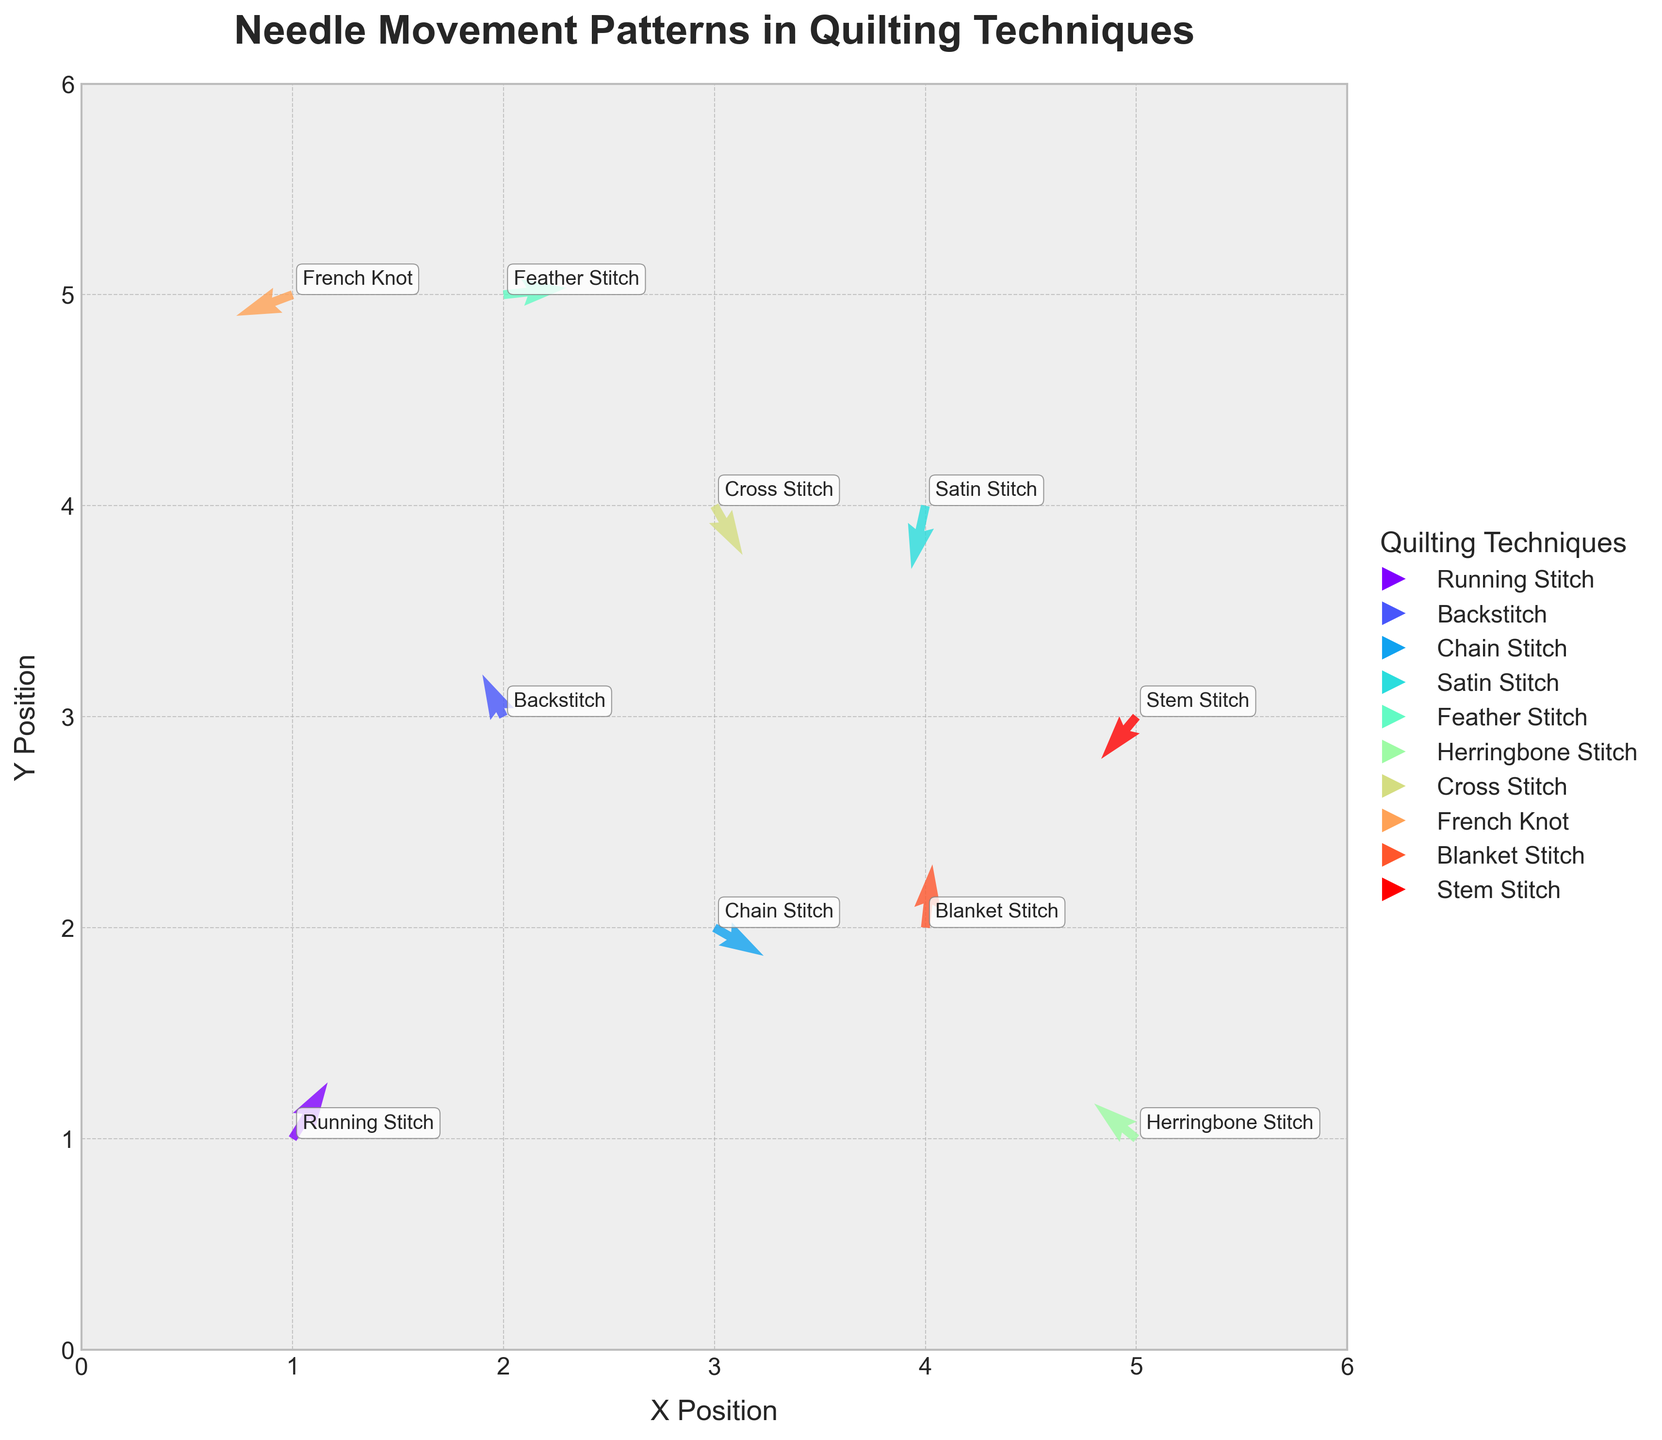What's the title of the figure? The title is usually placed at the top of the figure. By reading the top, we can see the title written there.
Answer: Needle Movement Patterns in Quilting Techniques How many different quilting techniques are represented? Each technique is annotated on the plot. By counting the annotations, we can find the total number. There are 10 annotations representing different techniques.
Answer: 10 Which quilting technique shows the longest needle movement in a single direction? To determine the longest movement, we look for the longest arrow vector, which corresponds to the largest magnitude of combined u and v values. Feather Stitch has the largest arrow vector, indicating the longest movement.
Answer: Feather Stitch What is the direction of the needle movement for Feather Stitch? The direction is shown by the arrow orientation. For Feather Stitch, the arrow points mostly to the right with a slight upward direction.
Answer: Right and slightly up Compare the speed of needle movements for Running Stitch and French Knot. Which is faster? The speed is determined by the length of the arrow vector. Running Stitch has a longer arrow compared to French Knot, indicating a faster speed.
Answer: Running Stitch Which quilting technique shows a downward and leftward movement? Direction is determined by the arrow's pointing. The Satin Stitch’s arrow points down and to the left.
Answer: Satin Stitch Which quilting technique shows the least amount of movement? The smallest arrow vector indicates the least movement. In this plot, French Knot has the shortest arrow vector.
Answer: French Knot What is the average value of horizontal movement (u) for Backstitch and Stem Stitch? The horizontal movement (u) for Backstitch is -0.3 and for Stem Stitch is -0.5. The average is calculated as (-0.3 + (-0.5)) / 2 = -0.4.
Answer: -0.4 What range of positions (x, y) does the plot cover? By observing the axis limits on the plot, we can determine the range. The x-axis and y-axis both cover the range from 0 to 6.
Answer: 0 to 6 